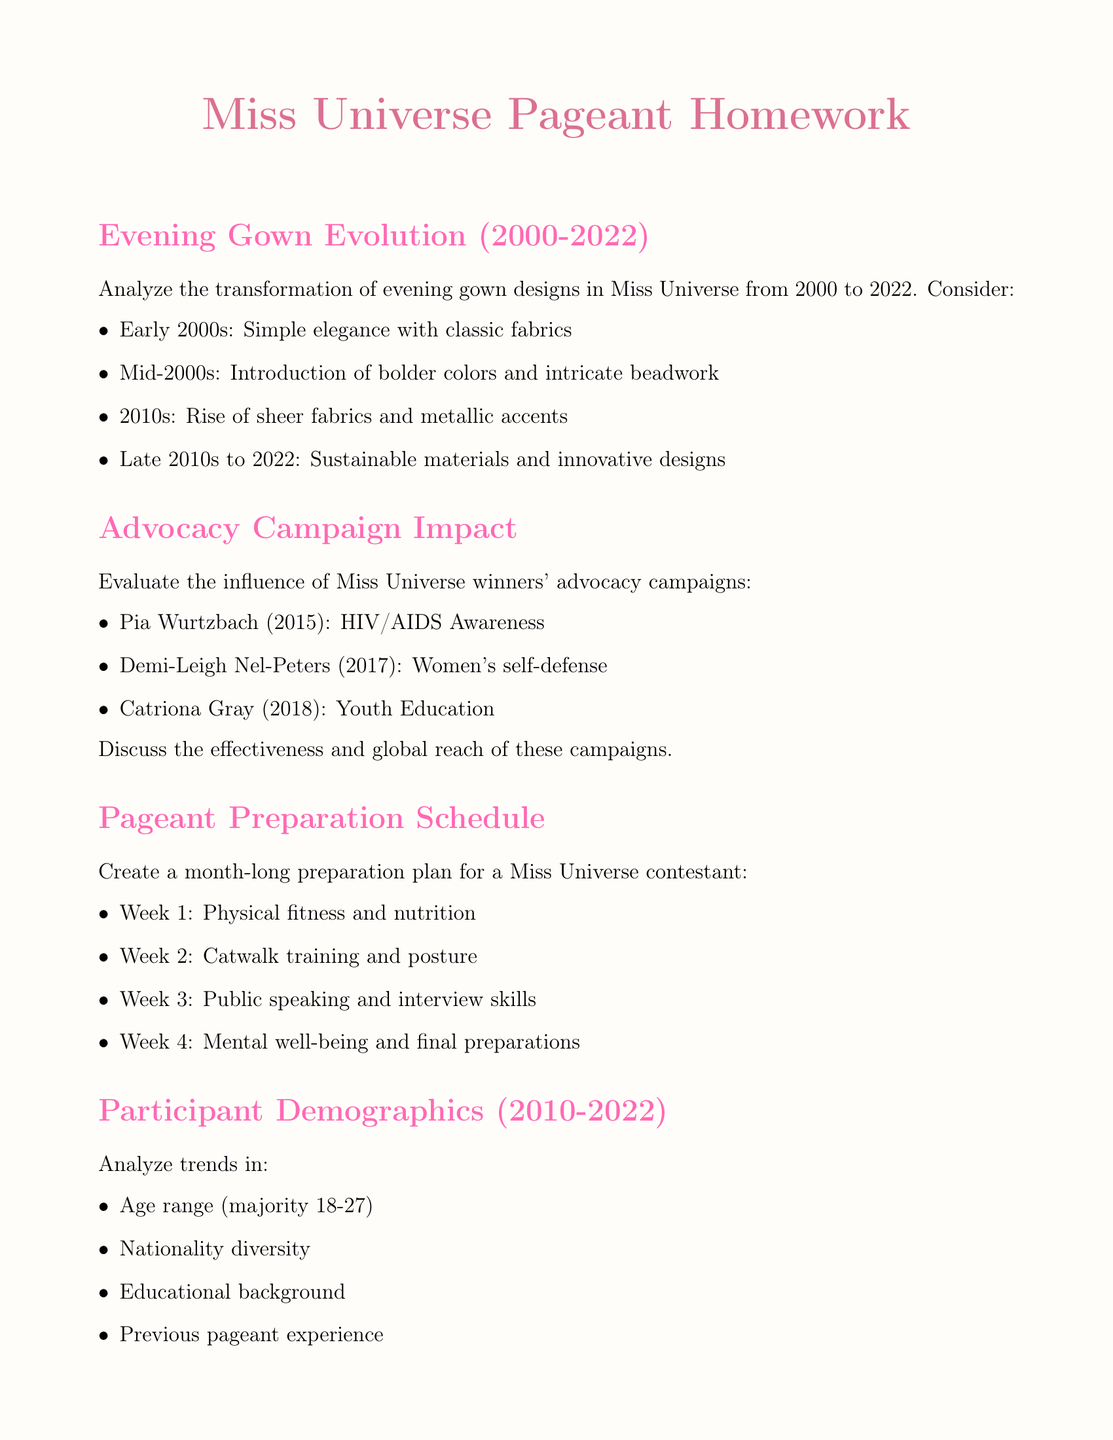What trends emerged in evening gown designs from 2000 to 2022? The document describes various fashion trends in Miss Universe evening gowns over the years, highlighting simple elegance, bolder colors, sheer fabrics, and sustainability.
Answer: Simple elegance, bolder colors, sheer fabrics, sustainability Who was the Miss Universe winner in 2015? The document lists Pia Wurtzbach as the Miss Universe winner of 2015 and mentions her advocacy effort.
Answer: Pia Wurtzbach What type of costume did India showcase in the national costumes section? The document notes India's national costume as a traditional lehenga.
Answer: Traditional Lehenga Which week of preparation focuses on public speaking and interview skills? The document outlines a weekly plan where Week 3 emphasizes public speaking and interview preparation.
Answer: Week 3 What is the majority age range for Miss Universe participants from 2010 to 2022? The document specifies that the majority age range of participants falls between 18-27 years.
Answer: 18-27 What advocacy issue did Demi-Leigh Nel-Peters focus on in 2017? The document mentions Demi-Leigh Nel-Peters' advocacy campaign centered on women's self-defense.
Answer: Women's self-defense What was the focus of Catriona Gray’s advocacy in 2018? The document indicates that Catriona Gray focused on youth education as her advocacy initiative.
Answer: Youth Education How many weeks does the preparation plan span? The document explicitly states that the preparation plan is crafted for a month, translating to four weeks.
Answer: Four weeks 